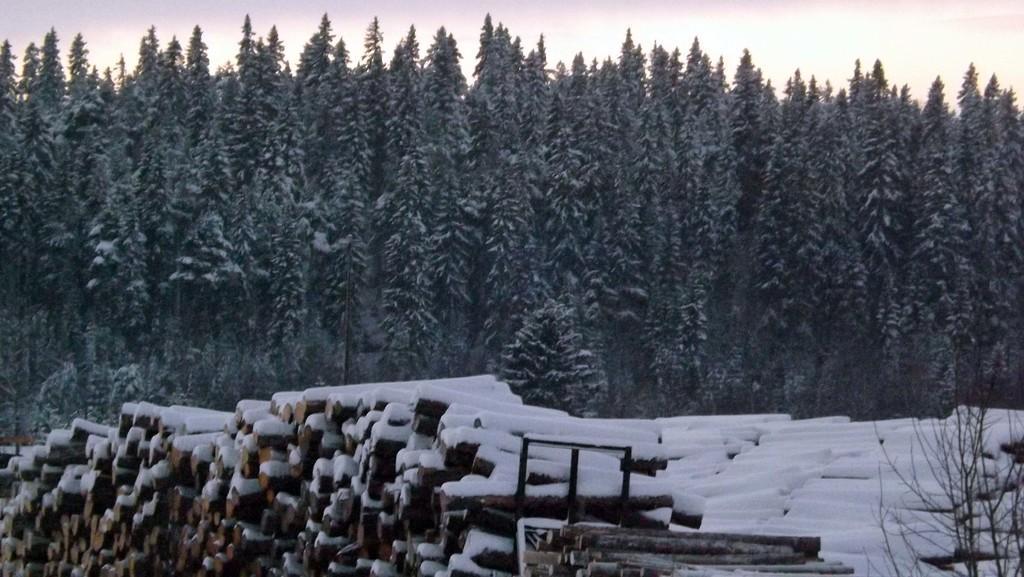Describe this image in one or two sentences. In this image, we can see some wooden objects covered with snow. In the background, we can see some trees. On the top, we can see the sky. 